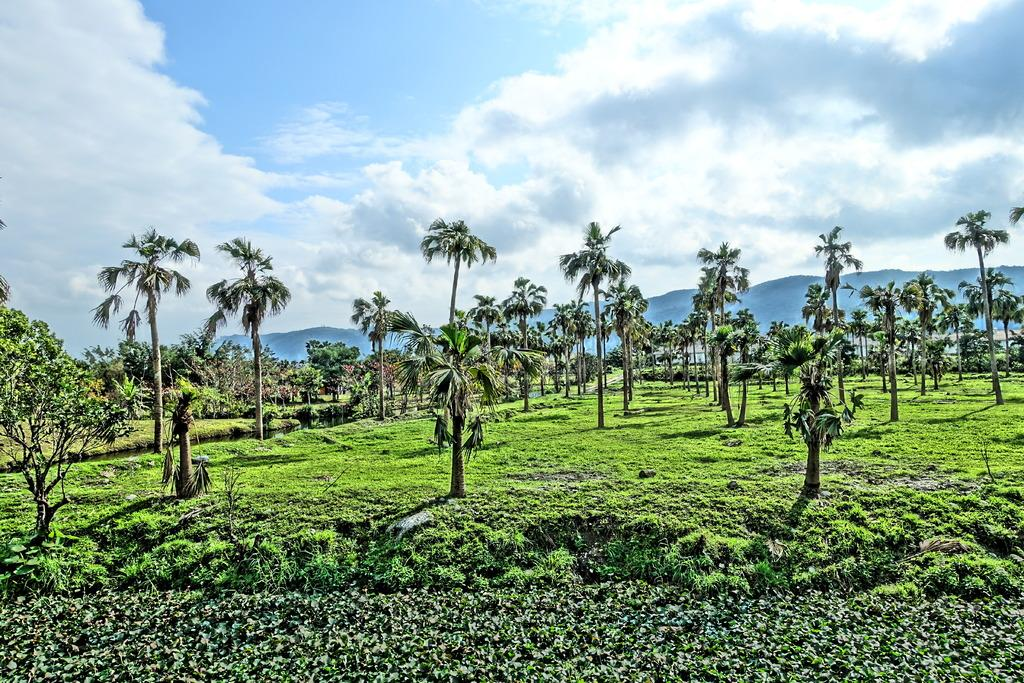What type of vegetation can be seen in the image? There are trees and plants in the image. What is visible on the ground in the image? The ground is visible in the image and has some grass. What type of terrain is present in the image? Hills are present in the image. What is visible in the sky in the image? The sky is visible in the image and has clouds. What type of butter is being used to solve the riddle in the image? There is no butter or riddle present in the image. 